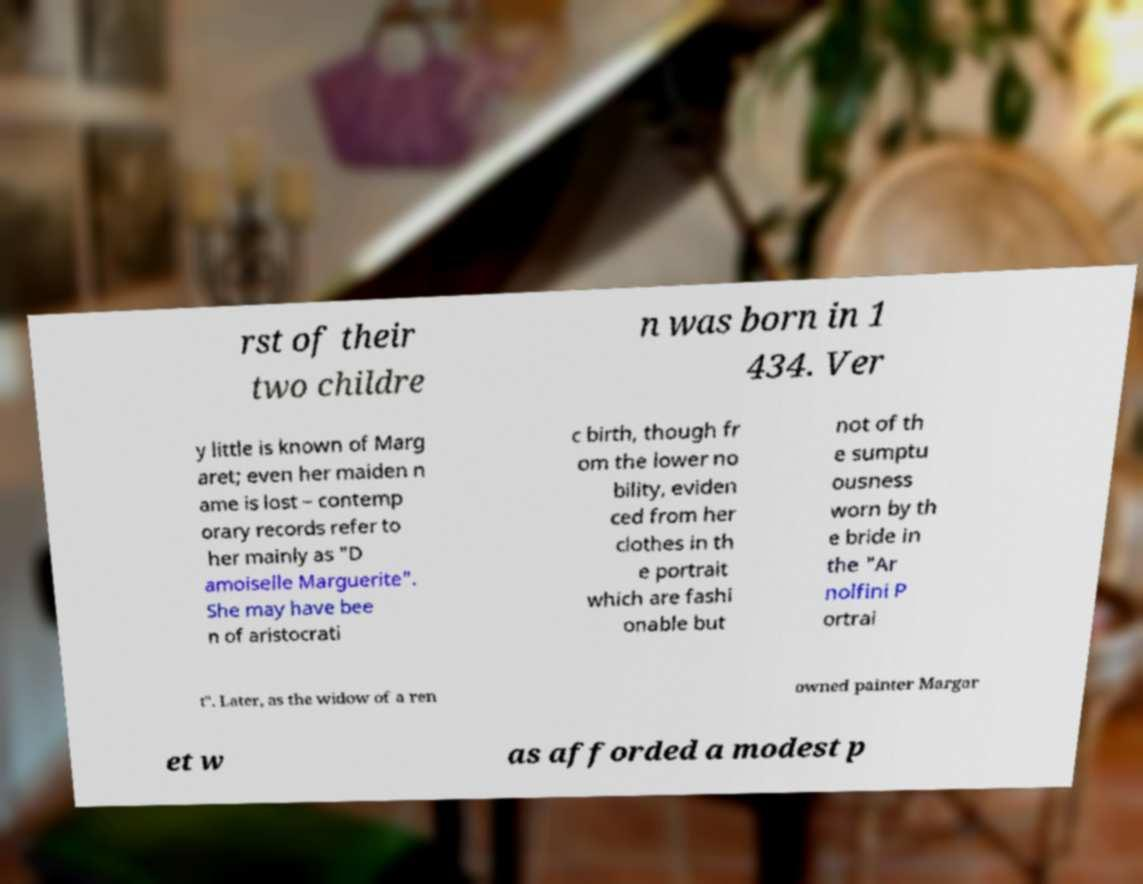Could you extract and type out the text from this image? rst of their two childre n was born in 1 434. Ver y little is known of Marg aret; even her maiden n ame is lost – contemp orary records refer to her mainly as "D amoiselle Marguerite". She may have bee n of aristocrati c birth, though fr om the lower no bility, eviden ced from her clothes in th e portrait which are fashi onable but not of th e sumptu ousness worn by th e bride in the "Ar nolfini P ortrai t". Later, as the widow of a ren owned painter Margar et w as afforded a modest p 